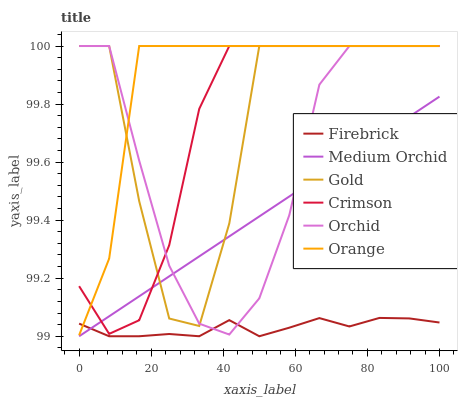Does Medium Orchid have the minimum area under the curve?
Answer yes or no. No. Does Medium Orchid have the maximum area under the curve?
Answer yes or no. No. Is Firebrick the smoothest?
Answer yes or no. No. Is Firebrick the roughest?
Answer yes or no. No. Does Orange have the lowest value?
Answer yes or no. No. Does Medium Orchid have the highest value?
Answer yes or no. No. Is Firebrick less than Gold?
Answer yes or no. Yes. Is Crimson greater than Firebrick?
Answer yes or no. Yes. Does Firebrick intersect Gold?
Answer yes or no. No. 